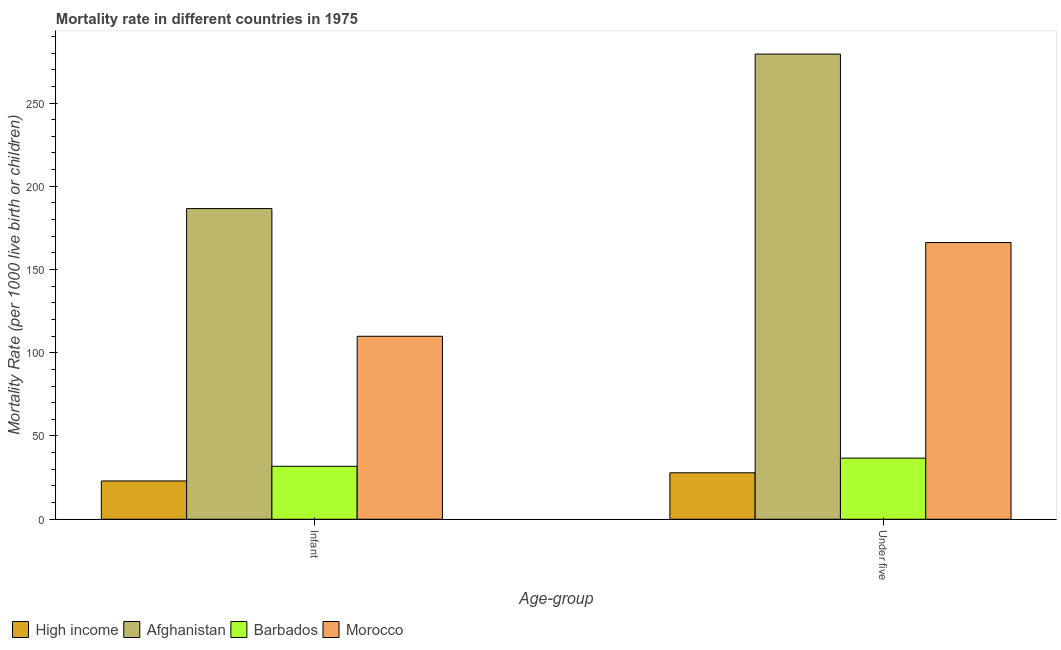How many bars are there on the 2nd tick from the right?
Provide a succinct answer. 4. What is the label of the 2nd group of bars from the left?
Ensure brevity in your answer.  Under five. What is the under-5 mortality rate in Morocco?
Keep it short and to the point. 166.2. Across all countries, what is the maximum under-5 mortality rate?
Offer a terse response. 279.4. In which country was the infant mortality rate maximum?
Your response must be concise. Afghanistan. What is the total under-5 mortality rate in the graph?
Make the answer very short. 510.2. What is the difference between the under-5 mortality rate in Barbados and that in High income?
Make the answer very short. 8.8. What is the difference between the infant mortality rate in Barbados and the under-5 mortality rate in High income?
Your answer should be very brief. 3.9. What is the average infant mortality rate per country?
Offer a terse response. 87.83. What is the difference between the under-5 mortality rate and infant mortality rate in High income?
Your answer should be compact. 4.9. What is the ratio of the infant mortality rate in Barbados to that in Afghanistan?
Provide a short and direct response. 0.17. Is the infant mortality rate in Barbados less than that in High income?
Give a very brief answer. No. What does the 3rd bar from the left in Under five represents?
Make the answer very short. Barbados. What does the 2nd bar from the right in Under five represents?
Give a very brief answer. Barbados. How many bars are there?
Provide a succinct answer. 8. Are the values on the major ticks of Y-axis written in scientific E-notation?
Keep it short and to the point. No. Where does the legend appear in the graph?
Keep it short and to the point. Bottom left. How are the legend labels stacked?
Provide a short and direct response. Horizontal. What is the title of the graph?
Provide a succinct answer. Mortality rate in different countries in 1975. What is the label or title of the X-axis?
Provide a short and direct response. Age-group. What is the label or title of the Y-axis?
Offer a terse response. Mortality Rate (per 1000 live birth or children). What is the Mortality Rate (per 1000 live birth or children) of High income in Infant?
Provide a short and direct response. 23. What is the Mortality Rate (per 1000 live birth or children) of Afghanistan in Infant?
Give a very brief answer. 186.6. What is the Mortality Rate (per 1000 live birth or children) in Barbados in Infant?
Your response must be concise. 31.8. What is the Mortality Rate (per 1000 live birth or children) of Morocco in Infant?
Your response must be concise. 109.9. What is the Mortality Rate (per 1000 live birth or children) of High income in Under five?
Ensure brevity in your answer.  27.9. What is the Mortality Rate (per 1000 live birth or children) of Afghanistan in Under five?
Provide a succinct answer. 279.4. What is the Mortality Rate (per 1000 live birth or children) in Barbados in Under five?
Offer a terse response. 36.7. What is the Mortality Rate (per 1000 live birth or children) of Morocco in Under five?
Offer a very short reply. 166.2. Across all Age-group, what is the maximum Mortality Rate (per 1000 live birth or children) in High income?
Provide a short and direct response. 27.9. Across all Age-group, what is the maximum Mortality Rate (per 1000 live birth or children) in Afghanistan?
Your answer should be compact. 279.4. Across all Age-group, what is the maximum Mortality Rate (per 1000 live birth or children) of Barbados?
Ensure brevity in your answer.  36.7. Across all Age-group, what is the maximum Mortality Rate (per 1000 live birth or children) in Morocco?
Your answer should be very brief. 166.2. Across all Age-group, what is the minimum Mortality Rate (per 1000 live birth or children) of Afghanistan?
Offer a very short reply. 186.6. Across all Age-group, what is the minimum Mortality Rate (per 1000 live birth or children) of Barbados?
Offer a terse response. 31.8. Across all Age-group, what is the minimum Mortality Rate (per 1000 live birth or children) of Morocco?
Your answer should be compact. 109.9. What is the total Mortality Rate (per 1000 live birth or children) of High income in the graph?
Keep it short and to the point. 50.9. What is the total Mortality Rate (per 1000 live birth or children) of Afghanistan in the graph?
Your answer should be very brief. 466. What is the total Mortality Rate (per 1000 live birth or children) of Barbados in the graph?
Offer a very short reply. 68.5. What is the total Mortality Rate (per 1000 live birth or children) in Morocco in the graph?
Give a very brief answer. 276.1. What is the difference between the Mortality Rate (per 1000 live birth or children) of Afghanistan in Infant and that in Under five?
Keep it short and to the point. -92.8. What is the difference between the Mortality Rate (per 1000 live birth or children) of Morocco in Infant and that in Under five?
Provide a succinct answer. -56.3. What is the difference between the Mortality Rate (per 1000 live birth or children) in High income in Infant and the Mortality Rate (per 1000 live birth or children) in Afghanistan in Under five?
Provide a short and direct response. -256.4. What is the difference between the Mortality Rate (per 1000 live birth or children) of High income in Infant and the Mortality Rate (per 1000 live birth or children) of Barbados in Under five?
Your answer should be compact. -13.7. What is the difference between the Mortality Rate (per 1000 live birth or children) of High income in Infant and the Mortality Rate (per 1000 live birth or children) of Morocco in Under five?
Offer a terse response. -143.2. What is the difference between the Mortality Rate (per 1000 live birth or children) of Afghanistan in Infant and the Mortality Rate (per 1000 live birth or children) of Barbados in Under five?
Offer a very short reply. 149.9. What is the difference between the Mortality Rate (per 1000 live birth or children) in Afghanistan in Infant and the Mortality Rate (per 1000 live birth or children) in Morocco in Under five?
Offer a terse response. 20.4. What is the difference between the Mortality Rate (per 1000 live birth or children) of Barbados in Infant and the Mortality Rate (per 1000 live birth or children) of Morocco in Under five?
Your answer should be very brief. -134.4. What is the average Mortality Rate (per 1000 live birth or children) of High income per Age-group?
Provide a short and direct response. 25.45. What is the average Mortality Rate (per 1000 live birth or children) in Afghanistan per Age-group?
Provide a short and direct response. 233. What is the average Mortality Rate (per 1000 live birth or children) in Barbados per Age-group?
Offer a very short reply. 34.25. What is the average Mortality Rate (per 1000 live birth or children) in Morocco per Age-group?
Provide a short and direct response. 138.05. What is the difference between the Mortality Rate (per 1000 live birth or children) in High income and Mortality Rate (per 1000 live birth or children) in Afghanistan in Infant?
Provide a succinct answer. -163.6. What is the difference between the Mortality Rate (per 1000 live birth or children) of High income and Mortality Rate (per 1000 live birth or children) of Morocco in Infant?
Offer a very short reply. -86.9. What is the difference between the Mortality Rate (per 1000 live birth or children) of Afghanistan and Mortality Rate (per 1000 live birth or children) of Barbados in Infant?
Ensure brevity in your answer.  154.8. What is the difference between the Mortality Rate (per 1000 live birth or children) in Afghanistan and Mortality Rate (per 1000 live birth or children) in Morocco in Infant?
Give a very brief answer. 76.7. What is the difference between the Mortality Rate (per 1000 live birth or children) of Barbados and Mortality Rate (per 1000 live birth or children) of Morocco in Infant?
Provide a succinct answer. -78.1. What is the difference between the Mortality Rate (per 1000 live birth or children) in High income and Mortality Rate (per 1000 live birth or children) in Afghanistan in Under five?
Offer a very short reply. -251.5. What is the difference between the Mortality Rate (per 1000 live birth or children) of High income and Mortality Rate (per 1000 live birth or children) of Morocco in Under five?
Your response must be concise. -138.3. What is the difference between the Mortality Rate (per 1000 live birth or children) of Afghanistan and Mortality Rate (per 1000 live birth or children) of Barbados in Under five?
Offer a terse response. 242.7. What is the difference between the Mortality Rate (per 1000 live birth or children) in Afghanistan and Mortality Rate (per 1000 live birth or children) in Morocco in Under five?
Keep it short and to the point. 113.2. What is the difference between the Mortality Rate (per 1000 live birth or children) in Barbados and Mortality Rate (per 1000 live birth or children) in Morocco in Under five?
Provide a succinct answer. -129.5. What is the ratio of the Mortality Rate (per 1000 live birth or children) of High income in Infant to that in Under five?
Provide a short and direct response. 0.82. What is the ratio of the Mortality Rate (per 1000 live birth or children) of Afghanistan in Infant to that in Under five?
Ensure brevity in your answer.  0.67. What is the ratio of the Mortality Rate (per 1000 live birth or children) in Barbados in Infant to that in Under five?
Keep it short and to the point. 0.87. What is the ratio of the Mortality Rate (per 1000 live birth or children) in Morocco in Infant to that in Under five?
Offer a very short reply. 0.66. What is the difference between the highest and the second highest Mortality Rate (per 1000 live birth or children) in Afghanistan?
Make the answer very short. 92.8. What is the difference between the highest and the second highest Mortality Rate (per 1000 live birth or children) of Morocco?
Make the answer very short. 56.3. What is the difference between the highest and the lowest Mortality Rate (per 1000 live birth or children) in High income?
Provide a short and direct response. 4.9. What is the difference between the highest and the lowest Mortality Rate (per 1000 live birth or children) in Afghanistan?
Offer a very short reply. 92.8. What is the difference between the highest and the lowest Mortality Rate (per 1000 live birth or children) of Morocco?
Your answer should be very brief. 56.3. 